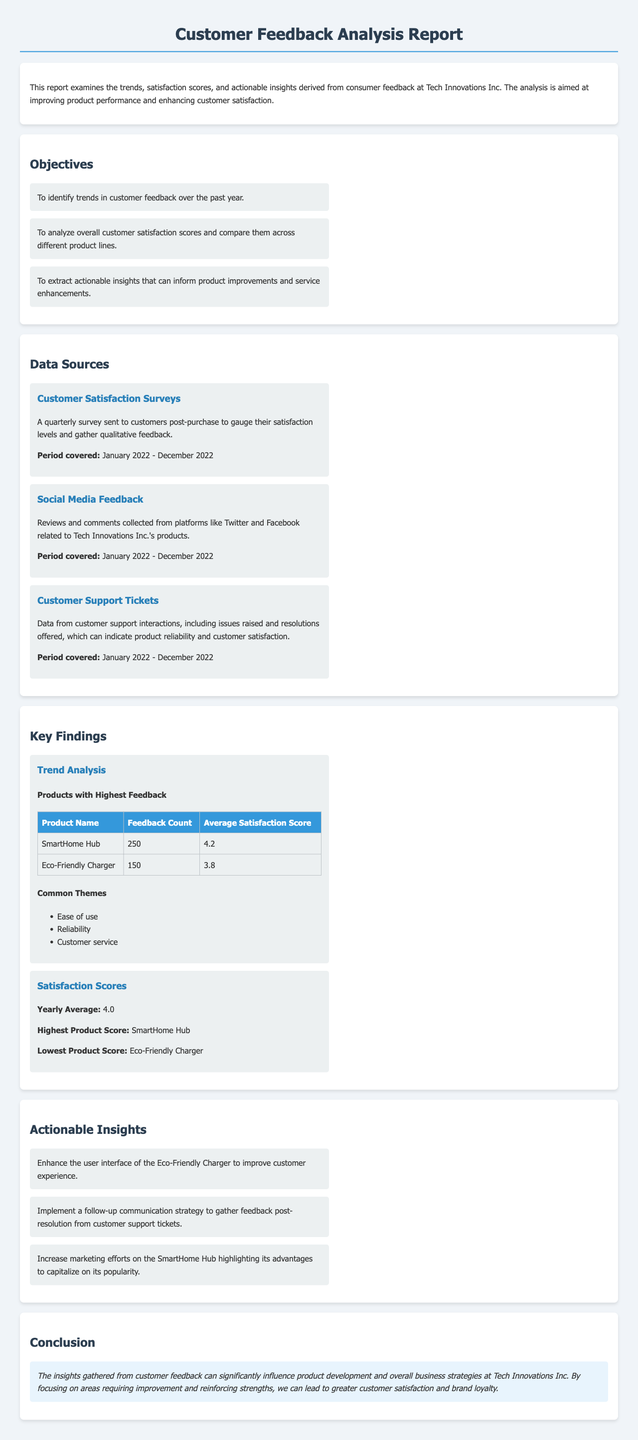What is the title of the report? The title is found at the top of the document, indicating the subject of the analysis.
Answer: Customer Feedback Analysis Report What is the period covered by the Customer Satisfaction Surveys? The period is stated within the data sources section, providing the timeframe for the feedback collected.
Answer: January 2022 - December 2022 How many feedback entries were collected for the SmartHome Hub? This information is detailed in the trend analysis subsection under key findings, showing the number of comments received.
Answer: 250 What is the highest product satisfaction score? The highest score is clearly indicated in the satisfaction scores section, showing the best-rated product.
Answer: SmartHome Hub What is one common theme from customer feedback? Common themes are listed under trend analysis, reflecting recurring topics in the feedback.
Answer: Ease of use What actionable insight is suggested for the Eco-Friendly Charger? The insight is detailed in the actionable insights section, directing improvements for this product.
Answer: Enhance the user interface What was the yearly average satisfaction score? This score is highlighted in the satisfaction scores section, summing up customer feedback for the year.
Answer: 4.0 What color is used for the headings in the report? The color of headings is mentioned in the style section, specifying how the document is formatted.
Answer: #2c3e50 What is the conclusion of the report? The conclusion summarizes the overall findings and their implications found at the end of the document.
Answer: The insights gathered from customer feedback can significantly influence product development and overall business strategies at Tech Innovations Inc 